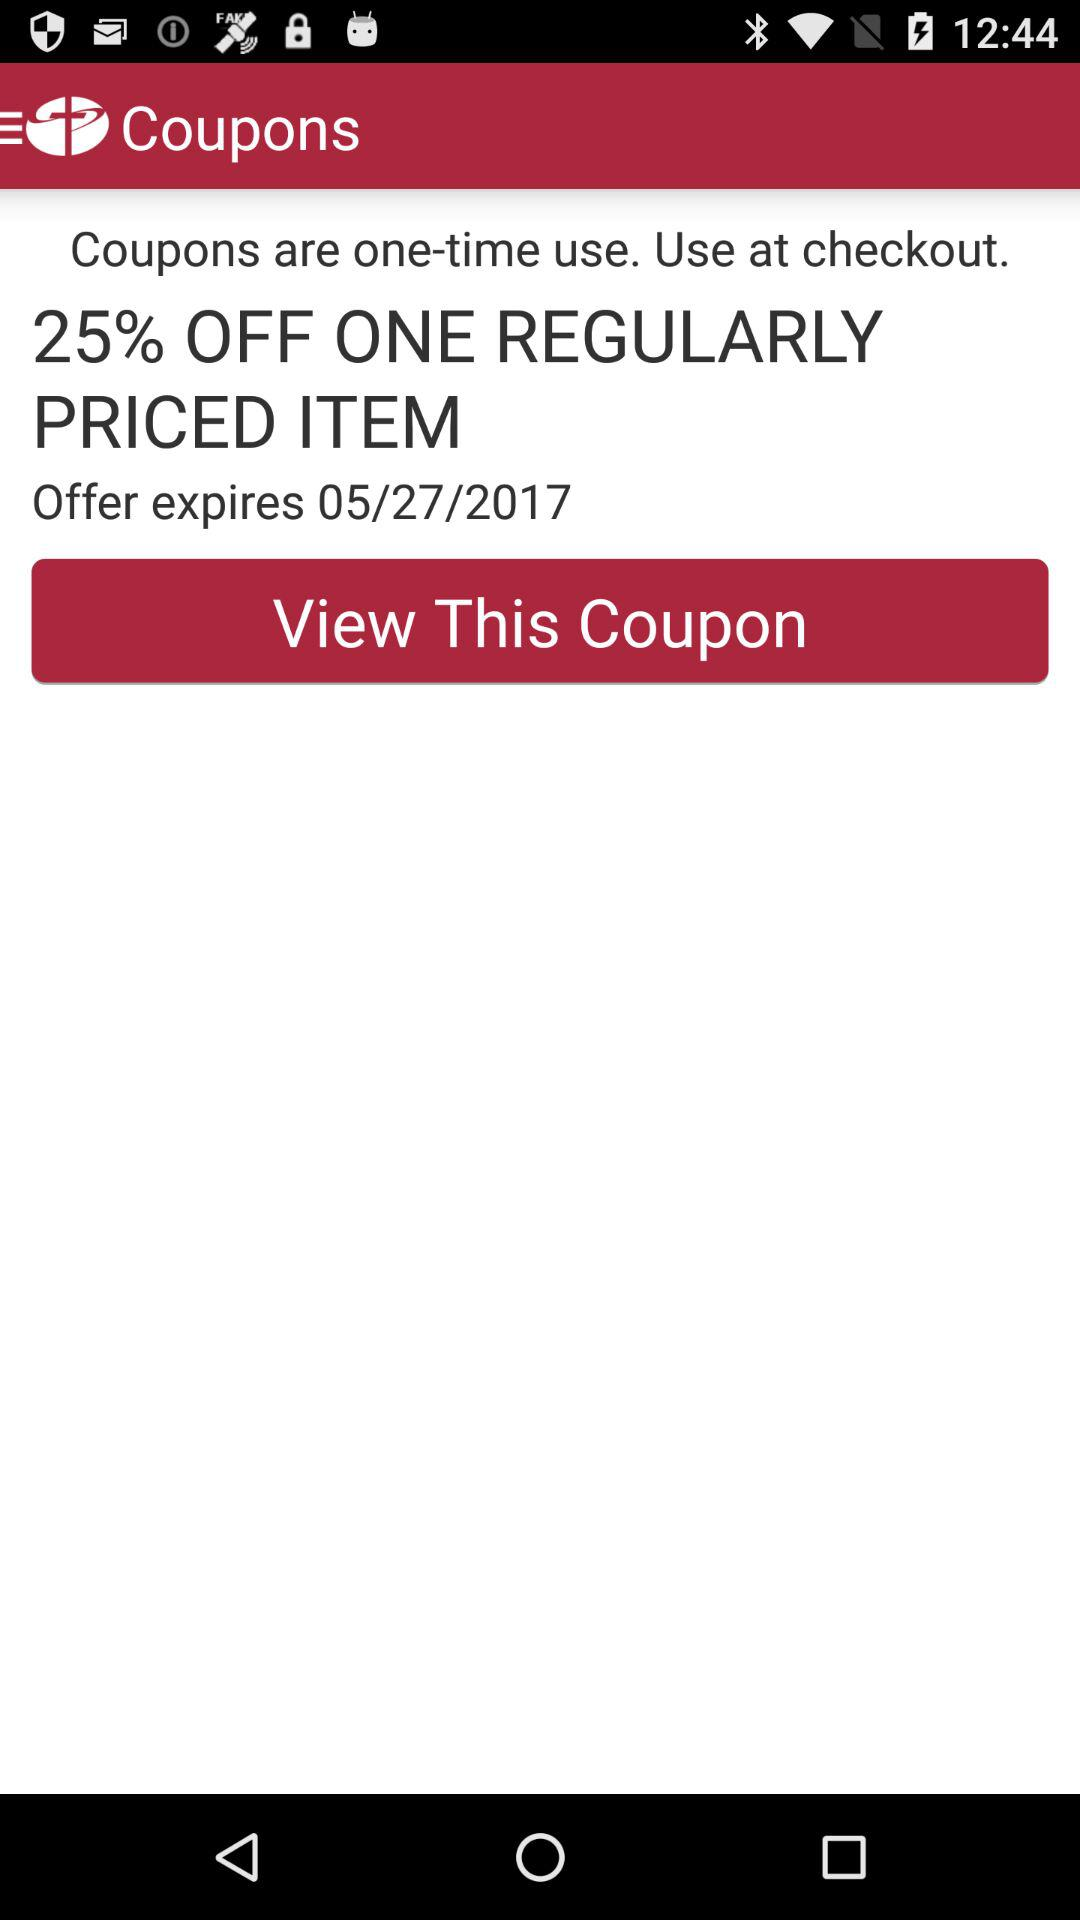What is the date on which the offer expires? The offer expires on May 27, 2017. 